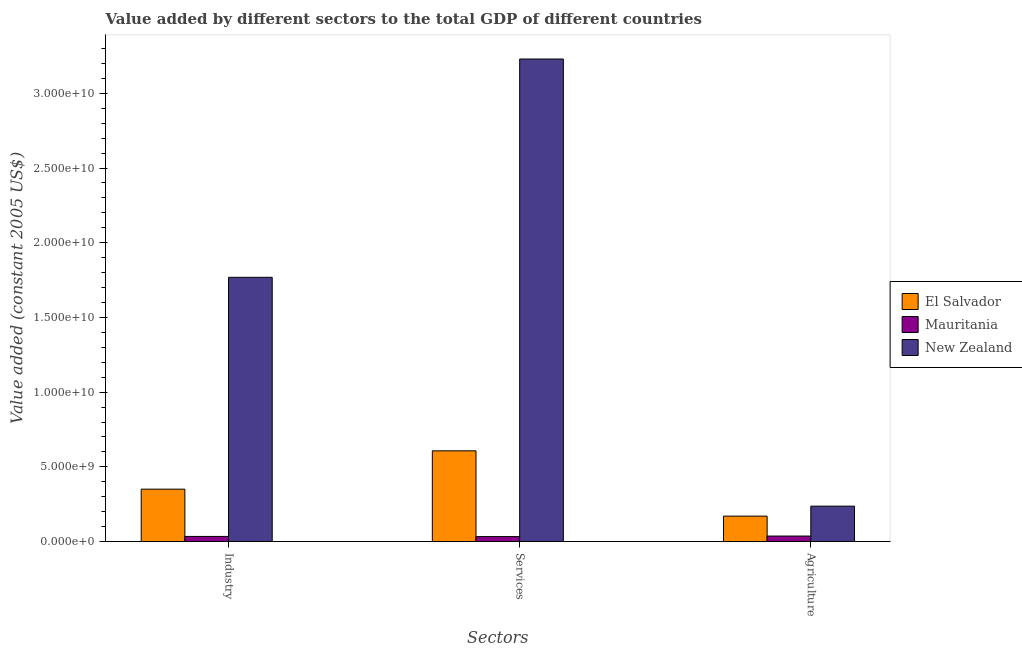How many different coloured bars are there?
Your answer should be compact. 3. Are the number of bars per tick equal to the number of legend labels?
Make the answer very short. Yes. Are the number of bars on each tick of the X-axis equal?
Offer a very short reply. Yes. What is the label of the 2nd group of bars from the left?
Give a very brief answer. Services. What is the value added by services in Mauritania?
Your answer should be very brief. 3.33e+08. Across all countries, what is the maximum value added by services?
Your response must be concise. 3.23e+1. Across all countries, what is the minimum value added by services?
Offer a terse response. 3.33e+08. In which country was the value added by services maximum?
Give a very brief answer. New Zealand. In which country was the value added by services minimum?
Offer a very short reply. Mauritania. What is the total value added by agricultural sector in the graph?
Provide a succinct answer. 4.44e+09. What is the difference between the value added by services in Mauritania and that in El Salvador?
Your response must be concise. -5.74e+09. What is the difference between the value added by services in El Salvador and the value added by industrial sector in Mauritania?
Provide a short and direct response. 5.73e+09. What is the average value added by industrial sector per country?
Keep it short and to the point. 7.18e+09. What is the difference between the value added by agricultural sector and value added by services in New Zealand?
Offer a very short reply. -2.99e+1. What is the ratio of the value added by industrial sector in El Salvador to that in New Zealand?
Provide a short and direct response. 0.2. Is the difference between the value added by services in Mauritania and El Salvador greater than the difference between the value added by agricultural sector in Mauritania and El Salvador?
Ensure brevity in your answer.  No. What is the difference between the highest and the second highest value added by agricultural sector?
Your answer should be compact. 6.67e+08. What is the difference between the highest and the lowest value added by agricultural sector?
Ensure brevity in your answer.  2.00e+09. In how many countries, is the value added by agricultural sector greater than the average value added by agricultural sector taken over all countries?
Your answer should be compact. 2. Is the sum of the value added by agricultural sector in New Zealand and Mauritania greater than the maximum value added by services across all countries?
Your answer should be very brief. No. What does the 1st bar from the left in Industry represents?
Make the answer very short. El Salvador. What does the 2nd bar from the right in Agriculture represents?
Ensure brevity in your answer.  Mauritania. How many bars are there?
Your answer should be very brief. 9. What is the difference between two consecutive major ticks on the Y-axis?
Your response must be concise. 5.00e+09. Are the values on the major ticks of Y-axis written in scientific E-notation?
Provide a short and direct response. Yes. Does the graph contain any zero values?
Offer a terse response. No. Does the graph contain grids?
Keep it short and to the point. No. Where does the legend appear in the graph?
Provide a succinct answer. Center right. How many legend labels are there?
Ensure brevity in your answer.  3. How are the legend labels stacked?
Offer a terse response. Vertical. What is the title of the graph?
Offer a terse response. Value added by different sectors to the total GDP of different countries. What is the label or title of the X-axis?
Your response must be concise. Sectors. What is the label or title of the Y-axis?
Your answer should be very brief. Value added (constant 2005 US$). What is the Value added (constant 2005 US$) in El Salvador in Industry?
Ensure brevity in your answer.  3.51e+09. What is the Value added (constant 2005 US$) in Mauritania in Industry?
Your response must be concise. 3.44e+08. What is the Value added (constant 2005 US$) of New Zealand in Industry?
Ensure brevity in your answer.  1.77e+1. What is the Value added (constant 2005 US$) of El Salvador in Services?
Offer a terse response. 6.07e+09. What is the Value added (constant 2005 US$) in Mauritania in Services?
Make the answer very short. 3.33e+08. What is the Value added (constant 2005 US$) in New Zealand in Services?
Provide a succinct answer. 3.23e+1. What is the Value added (constant 2005 US$) of El Salvador in Agriculture?
Keep it short and to the point. 1.70e+09. What is the Value added (constant 2005 US$) of Mauritania in Agriculture?
Keep it short and to the point. 3.69e+08. What is the Value added (constant 2005 US$) in New Zealand in Agriculture?
Provide a succinct answer. 2.37e+09. Across all Sectors, what is the maximum Value added (constant 2005 US$) of El Salvador?
Provide a short and direct response. 6.07e+09. Across all Sectors, what is the maximum Value added (constant 2005 US$) of Mauritania?
Keep it short and to the point. 3.69e+08. Across all Sectors, what is the maximum Value added (constant 2005 US$) of New Zealand?
Your response must be concise. 3.23e+1. Across all Sectors, what is the minimum Value added (constant 2005 US$) in El Salvador?
Your answer should be very brief. 1.70e+09. Across all Sectors, what is the minimum Value added (constant 2005 US$) of Mauritania?
Give a very brief answer. 3.33e+08. Across all Sectors, what is the minimum Value added (constant 2005 US$) in New Zealand?
Make the answer very short. 2.37e+09. What is the total Value added (constant 2005 US$) in El Salvador in the graph?
Offer a very short reply. 1.13e+1. What is the total Value added (constant 2005 US$) in Mauritania in the graph?
Provide a short and direct response. 1.05e+09. What is the total Value added (constant 2005 US$) in New Zealand in the graph?
Provide a short and direct response. 5.24e+1. What is the difference between the Value added (constant 2005 US$) of El Salvador in Industry and that in Services?
Make the answer very short. -2.57e+09. What is the difference between the Value added (constant 2005 US$) in Mauritania in Industry and that in Services?
Make the answer very short. 1.02e+07. What is the difference between the Value added (constant 2005 US$) of New Zealand in Industry and that in Services?
Your response must be concise. -1.46e+1. What is the difference between the Value added (constant 2005 US$) of El Salvador in Industry and that in Agriculture?
Make the answer very short. 1.80e+09. What is the difference between the Value added (constant 2005 US$) of Mauritania in Industry and that in Agriculture?
Ensure brevity in your answer.  -2.54e+07. What is the difference between the Value added (constant 2005 US$) in New Zealand in Industry and that in Agriculture?
Provide a succinct answer. 1.53e+1. What is the difference between the Value added (constant 2005 US$) in El Salvador in Services and that in Agriculture?
Offer a very short reply. 4.37e+09. What is the difference between the Value added (constant 2005 US$) in Mauritania in Services and that in Agriculture?
Your answer should be very brief. -3.55e+07. What is the difference between the Value added (constant 2005 US$) in New Zealand in Services and that in Agriculture?
Your answer should be compact. 2.99e+1. What is the difference between the Value added (constant 2005 US$) of El Salvador in Industry and the Value added (constant 2005 US$) of Mauritania in Services?
Provide a short and direct response. 3.17e+09. What is the difference between the Value added (constant 2005 US$) in El Salvador in Industry and the Value added (constant 2005 US$) in New Zealand in Services?
Make the answer very short. -2.88e+1. What is the difference between the Value added (constant 2005 US$) of Mauritania in Industry and the Value added (constant 2005 US$) of New Zealand in Services?
Provide a short and direct response. -3.20e+1. What is the difference between the Value added (constant 2005 US$) in El Salvador in Industry and the Value added (constant 2005 US$) in Mauritania in Agriculture?
Provide a short and direct response. 3.14e+09. What is the difference between the Value added (constant 2005 US$) of El Salvador in Industry and the Value added (constant 2005 US$) of New Zealand in Agriculture?
Ensure brevity in your answer.  1.14e+09. What is the difference between the Value added (constant 2005 US$) in Mauritania in Industry and the Value added (constant 2005 US$) in New Zealand in Agriculture?
Offer a terse response. -2.03e+09. What is the difference between the Value added (constant 2005 US$) in El Salvador in Services and the Value added (constant 2005 US$) in Mauritania in Agriculture?
Keep it short and to the point. 5.70e+09. What is the difference between the Value added (constant 2005 US$) of El Salvador in Services and the Value added (constant 2005 US$) of New Zealand in Agriculture?
Provide a short and direct response. 3.70e+09. What is the difference between the Value added (constant 2005 US$) of Mauritania in Services and the Value added (constant 2005 US$) of New Zealand in Agriculture?
Your answer should be compact. -2.04e+09. What is the average Value added (constant 2005 US$) in El Salvador per Sectors?
Provide a succinct answer. 3.76e+09. What is the average Value added (constant 2005 US$) of Mauritania per Sectors?
Your answer should be very brief. 3.49e+08. What is the average Value added (constant 2005 US$) of New Zealand per Sectors?
Your response must be concise. 1.75e+1. What is the difference between the Value added (constant 2005 US$) of El Salvador and Value added (constant 2005 US$) of Mauritania in Industry?
Your answer should be compact. 3.16e+09. What is the difference between the Value added (constant 2005 US$) in El Salvador and Value added (constant 2005 US$) in New Zealand in Industry?
Your answer should be very brief. -1.42e+1. What is the difference between the Value added (constant 2005 US$) of Mauritania and Value added (constant 2005 US$) of New Zealand in Industry?
Your answer should be very brief. -1.73e+1. What is the difference between the Value added (constant 2005 US$) of El Salvador and Value added (constant 2005 US$) of Mauritania in Services?
Keep it short and to the point. 5.74e+09. What is the difference between the Value added (constant 2005 US$) in El Salvador and Value added (constant 2005 US$) in New Zealand in Services?
Give a very brief answer. -2.62e+1. What is the difference between the Value added (constant 2005 US$) in Mauritania and Value added (constant 2005 US$) in New Zealand in Services?
Make the answer very short. -3.20e+1. What is the difference between the Value added (constant 2005 US$) in El Salvador and Value added (constant 2005 US$) in Mauritania in Agriculture?
Give a very brief answer. 1.33e+09. What is the difference between the Value added (constant 2005 US$) in El Salvador and Value added (constant 2005 US$) in New Zealand in Agriculture?
Offer a very short reply. -6.67e+08. What is the difference between the Value added (constant 2005 US$) in Mauritania and Value added (constant 2005 US$) in New Zealand in Agriculture?
Your answer should be very brief. -2.00e+09. What is the ratio of the Value added (constant 2005 US$) of El Salvador in Industry to that in Services?
Make the answer very short. 0.58. What is the ratio of the Value added (constant 2005 US$) of Mauritania in Industry to that in Services?
Offer a terse response. 1.03. What is the ratio of the Value added (constant 2005 US$) of New Zealand in Industry to that in Services?
Your answer should be very brief. 0.55. What is the ratio of the Value added (constant 2005 US$) of El Salvador in Industry to that in Agriculture?
Keep it short and to the point. 2.06. What is the ratio of the Value added (constant 2005 US$) in Mauritania in Industry to that in Agriculture?
Ensure brevity in your answer.  0.93. What is the ratio of the Value added (constant 2005 US$) of New Zealand in Industry to that in Agriculture?
Give a very brief answer. 7.46. What is the ratio of the Value added (constant 2005 US$) in El Salvador in Services to that in Agriculture?
Offer a terse response. 3.56. What is the ratio of the Value added (constant 2005 US$) in Mauritania in Services to that in Agriculture?
Keep it short and to the point. 0.9. What is the ratio of the Value added (constant 2005 US$) in New Zealand in Services to that in Agriculture?
Provide a succinct answer. 13.63. What is the difference between the highest and the second highest Value added (constant 2005 US$) in El Salvador?
Offer a terse response. 2.57e+09. What is the difference between the highest and the second highest Value added (constant 2005 US$) in Mauritania?
Your answer should be very brief. 2.54e+07. What is the difference between the highest and the second highest Value added (constant 2005 US$) of New Zealand?
Keep it short and to the point. 1.46e+1. What is the difference between the highest and the lowest Value added (constant 2005 US$) in El Salvador?
Your response must be concise. 4.37e+09. What is the difference between the highest and the lowest Value added (constant 2005 US$) of Mauritania?
Make the answer very short. 3.55e+07. What is the difference between the highest and the lowest Value added (constant 2005 US$) of New Zealand?
Your response must be concise. 2.99e+1. 